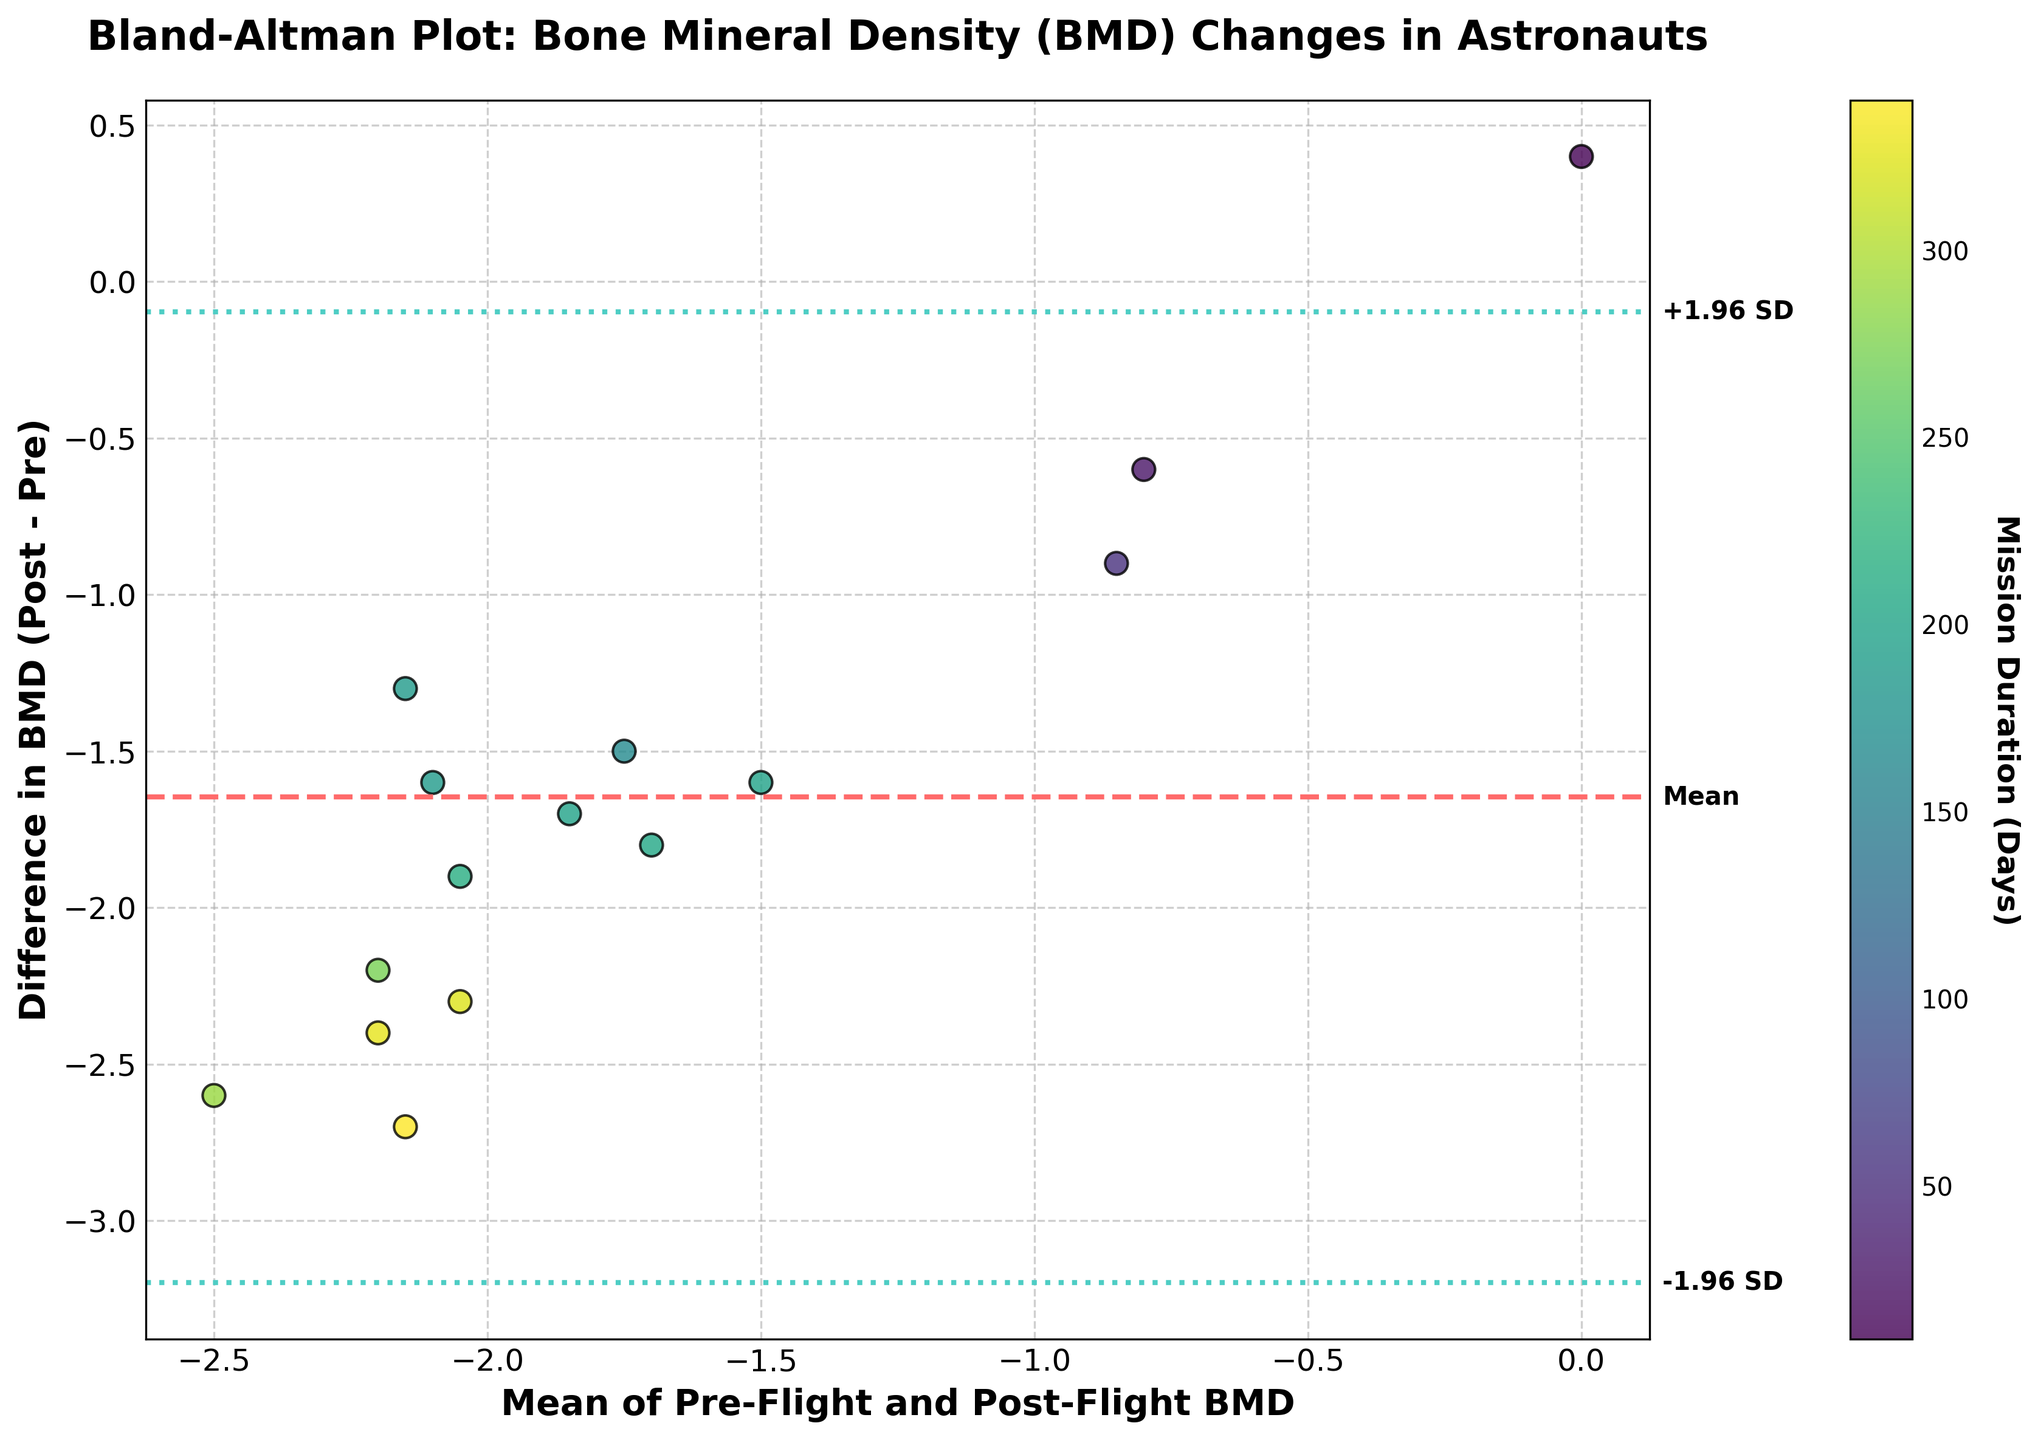How many data points are represented in the figure? Count the number of data points by identifying the individual markers in the figure. Each marker represents an astronaut.
Answer: 15 What do the colors of the data points represent? The colors of the data points represent the mission duration in days, as indicated by the colorbar on the right side of the figure.
Answer: Mission duration What is the title of the figure? Refer to the top of the figure where the title is located.
Answer: Bland-Altman Plot: Bone Mineral Density (BMD) Changes in Astronauts What is the significance of the dashed horizontal line in the plot? The dashed horizontal line represents the mean difference between the pre-flight and post-flight BMD measurements.
Answer: Mean difference Compare the difference in BMD between the astronaut with the shortest mission duration and the astronaut with the longest mission duration. Identify the data points corresponding to the shortest (9 days) and longest (340 days) mission durations, and then compare the their differences in BMD.
Answer: 0.4 (shortest) and -2.7 (longest) What does the value of the mean difference signify? The mean difference, which can be read from the location of the dashed horizontal line, signifies the average change in BMD from pre-flight to post-flight.
Answer: Around -1.56 Between which values are the limits of agreement? Identify the two dotted lines representing the limits of agreement and extract their corresponding y-values.
Answer: Approximately -0.07 and -3.05 Is there a noticeable trend between mission duration and BMD difference? Refer to the color of the data points as well as the pattern of changes in BMD differences. Generally, longer mission durations tend to show larger differences in BMD.
Answer: Yes What is the range of the mean BMD values (x-axis)? Determine the range by finding the minimum and maximum values of the x-axis scale, where the mean BMD values are plotted.
Answer: Approximately -2.5 to 0.2 Which astronaut experienced the least change in BMD? Identify the data point with the smallest difference (near zero) in BMD, which can be cross-referenced with the mission durations and astronaut names provided.
Answer: John Glenn 